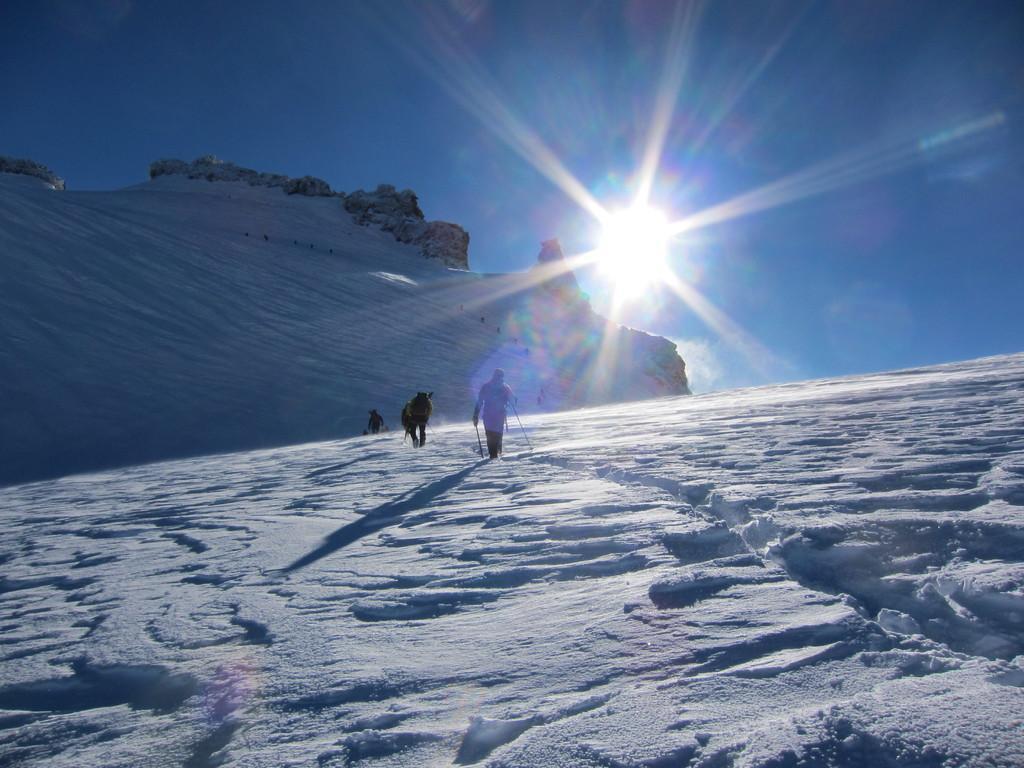Could you give a brief overview of what you see in this image? In the middle of the image few people are walking and holding sticks. Behind them there are some hills. At the top of the image there is sun and sky. 